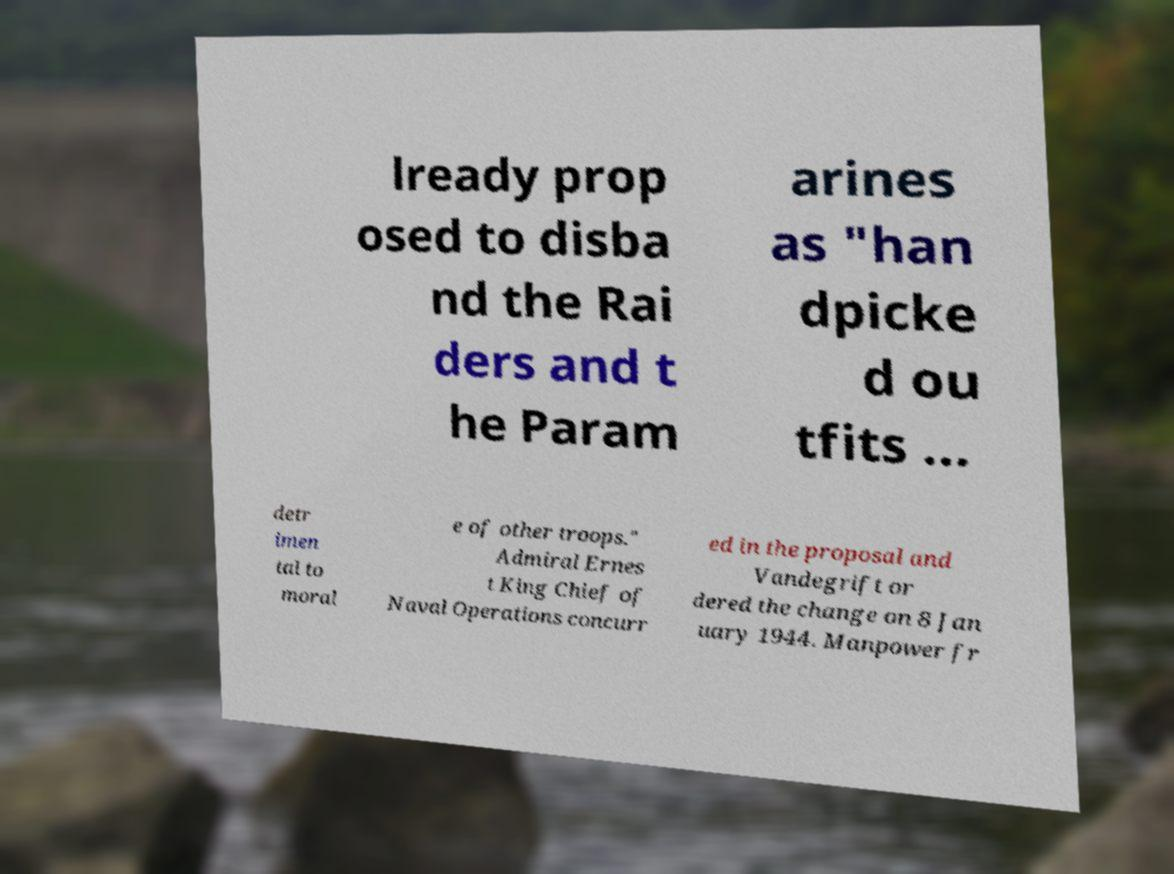Please read and relay the text visible in this image. What does it say? lready prop osed to disba nd the Rai ders and t he Param arines as "han dpicke d ou tfits ... detr imen tal to moral e of other troops." Admiral Ernes t King Chief of Naval Operations concurr ed in the proposal and Vandegrift or dered the change on 8 Jan uary 1944. Manpower fr 